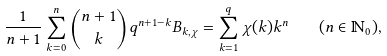<formula> <loc_0><loc_0><loc_500><loc_500>\frac { 1 } { n + 1 } \sum ^ { n } _ { k = 0 } { n + 1 \choose { k } } q ^ { n + 1 - k } B _ { k , \chi } = \sum ^ { q } _ { k = 1 } \chi ( k ) k ^ { n } \quad ( n \in \mathbb { N } _ { 0 } ) ,</formula> 